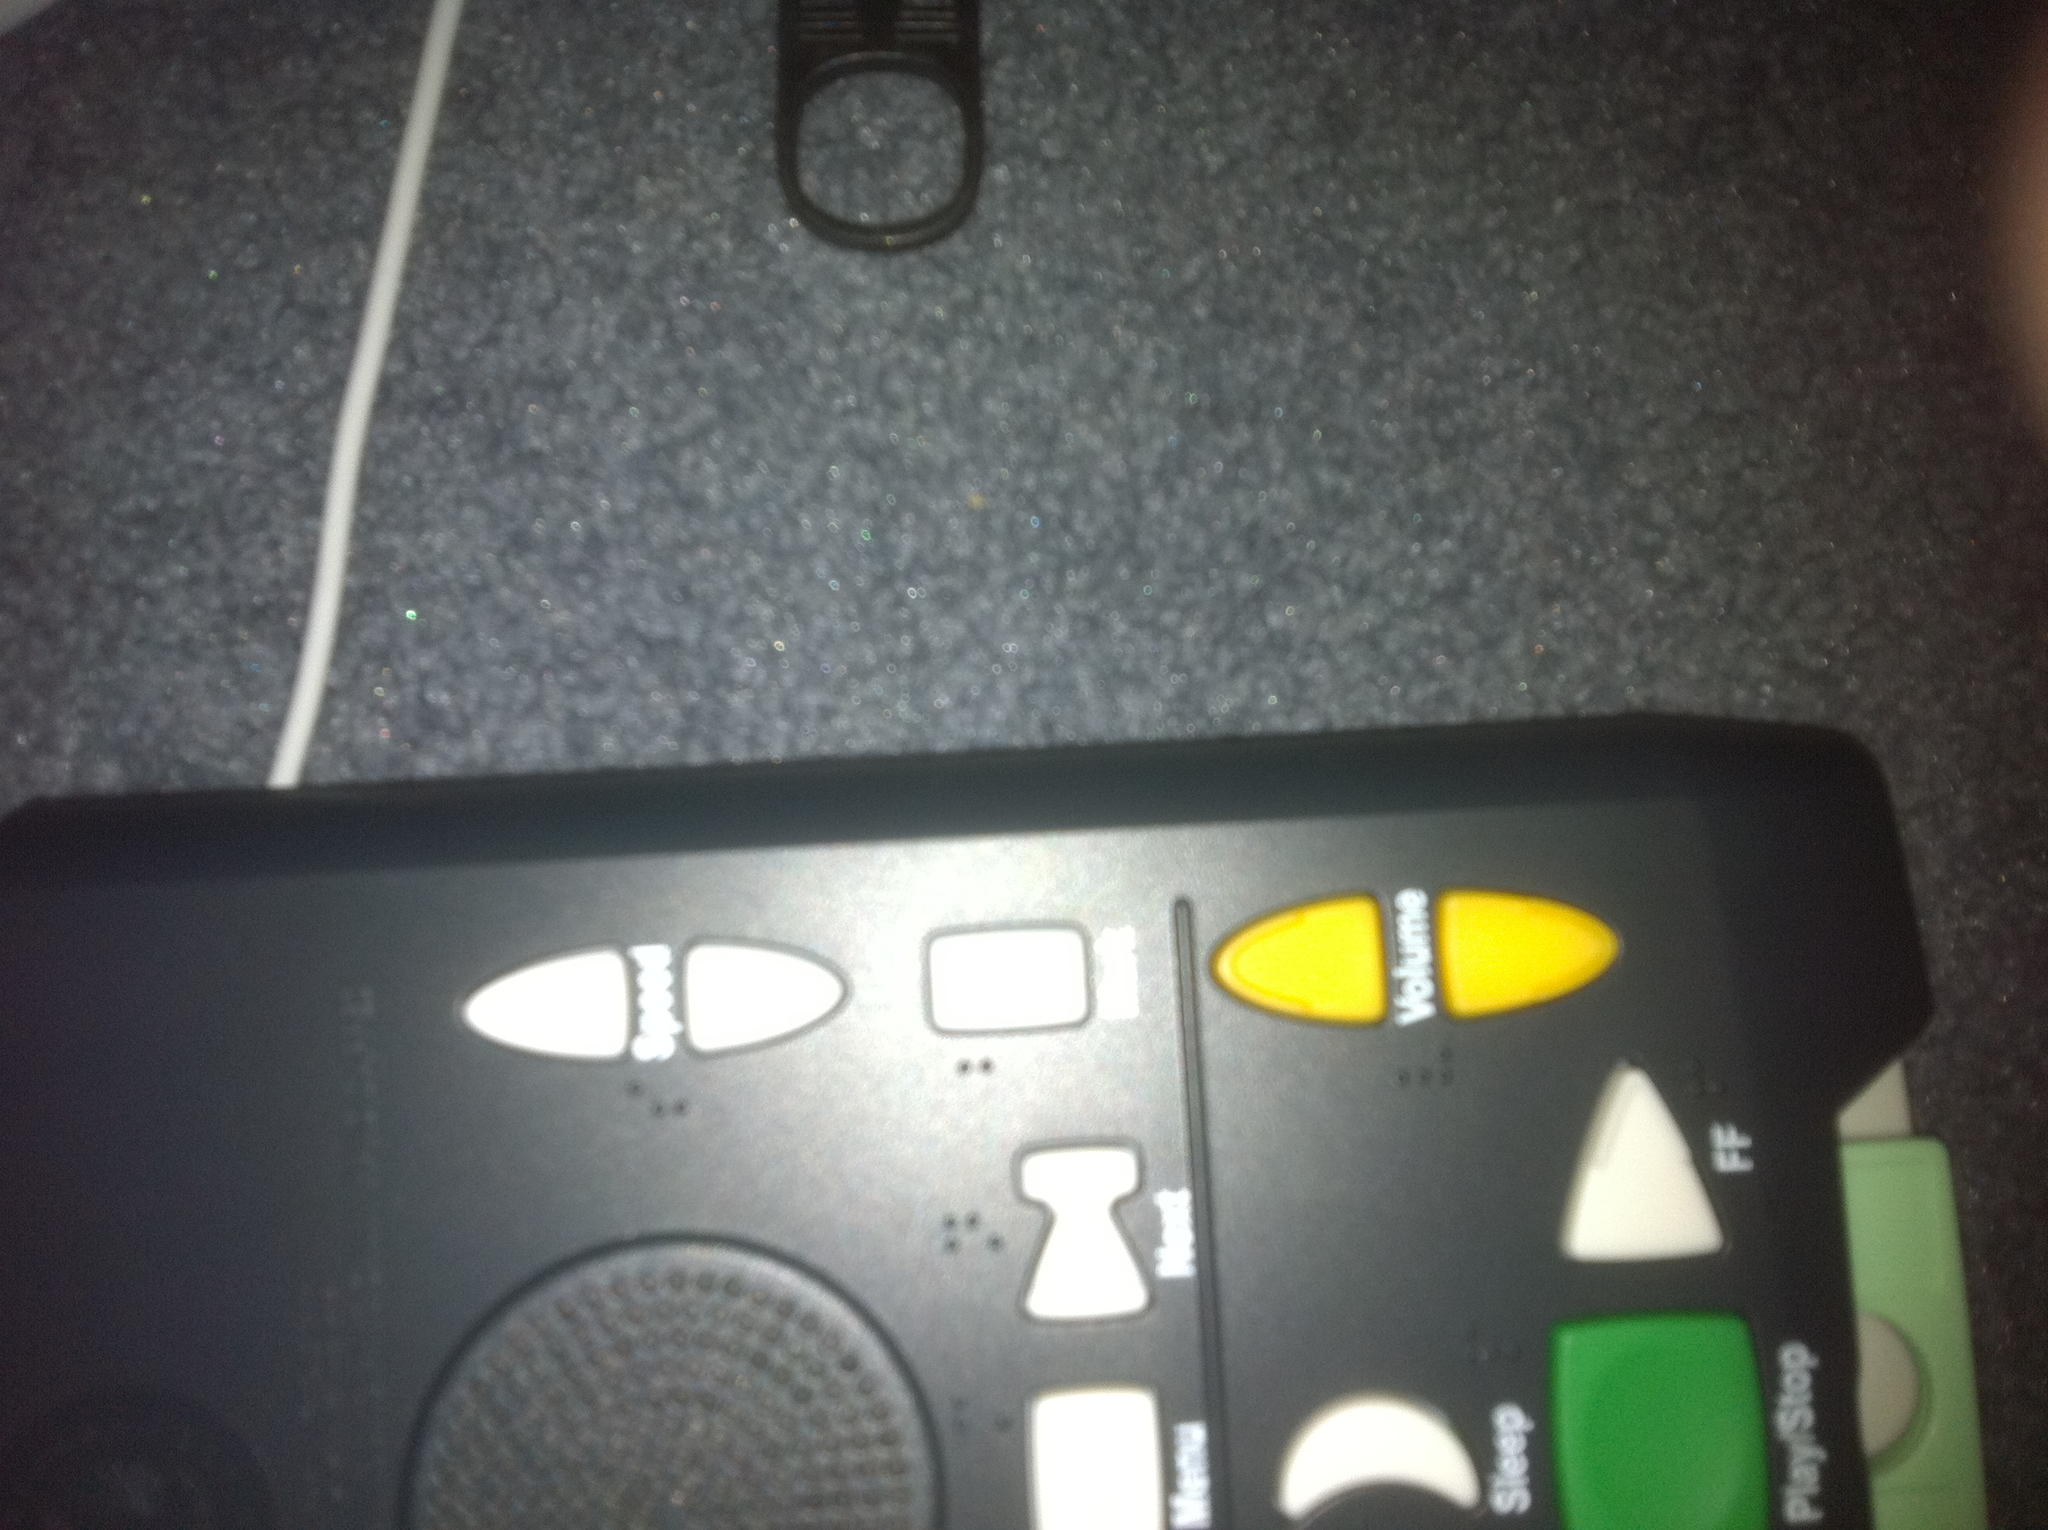Can you describe the functions associated with the visible buttons on this remote control? Certainly! The remote control has several distinct buttons: 'Speed' for adjusting playback speed, 'Menu' for accessing system menus, and 'Volume', which has a plus and minus to control the sound level. It also includes a 'Play/Stop' button at the bottom. 